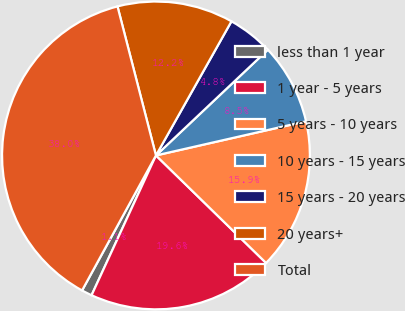Convert chart. <chart><loc_0><loc_0><loc_500><loc_500><pie_chart><fcel>less than 1 year<fcel>1 year - 5 years<fcel>5 years - 10 years<fcel>10 years - 15 years<fcel>15 years - 20 years<fcel>20 years+<fcel>Total<nl><fcel>1.1%<fcel>19.56%<fcel>15.87%<fcel>8.49%<fcel>4.79%<fcel>12.18%<fcel>38.01%<nl></chart> 